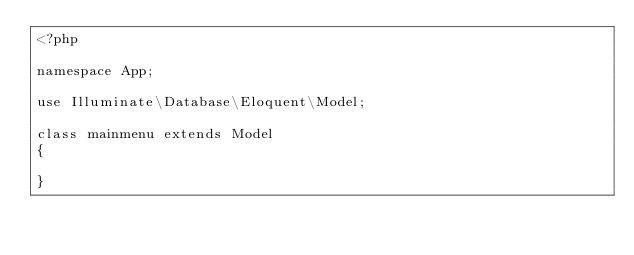Convert code to text. <code><loc_0><loc_0><loc_500><loc_500><_PHP_><?php

namespace App;

use Illuminate\Database\Eloquent\Model;

class mainmenu extends Model
{
  
}
</code> 